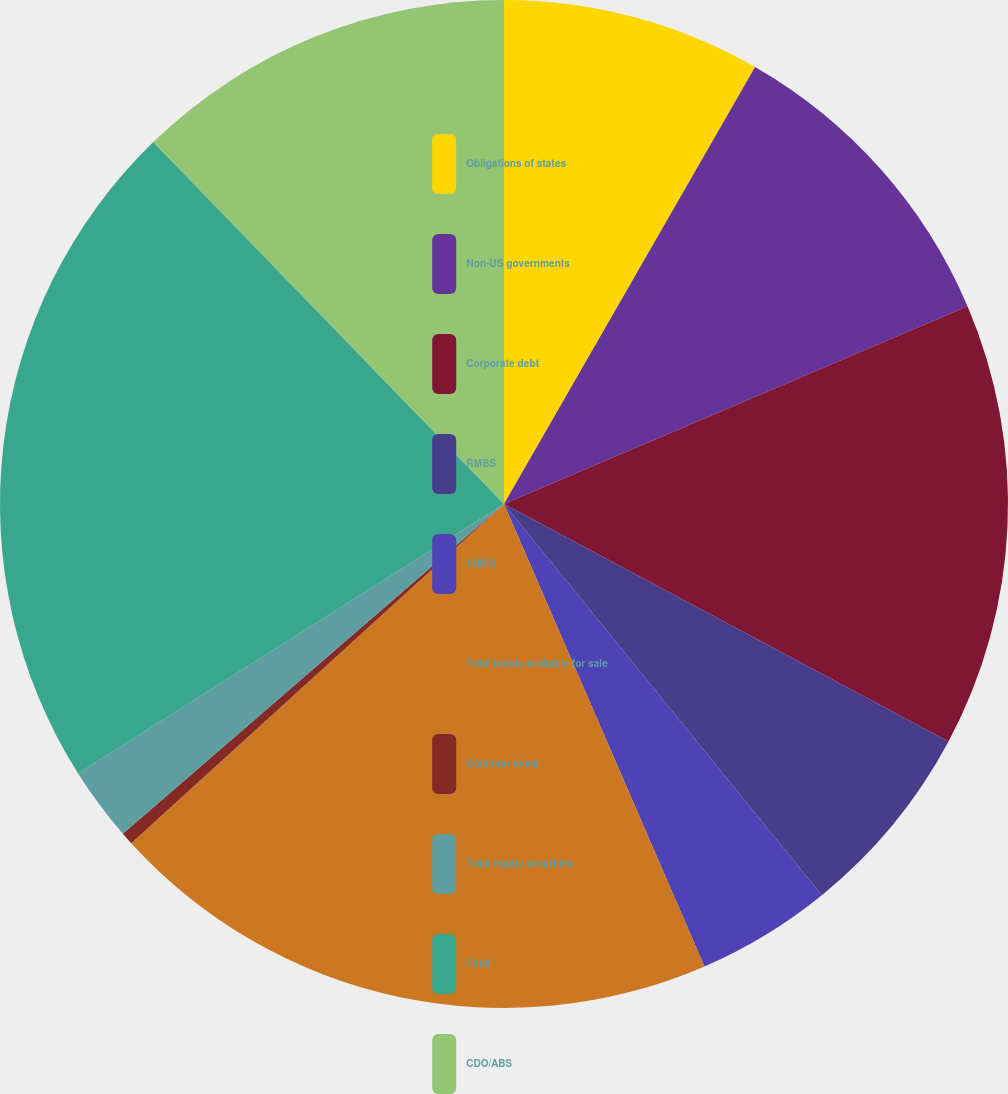Convert chart to OTSL. <chart><loc_0><loc_0><loc_500><loc_500><pie_chart><fcel>Obligations of states<fcel>Non-US governments<fcel>Corporate debt<fcel>RMBS<fcel>CMBS<fcel>Total bonds available for sale<fcel>Common stock<fcel>Total equity securities<fcel>Total<fcel>CDO/ABS<nl><fcel>8.3%<fcel>10.28%<fcel>14.23%<fcel>6.33%<fcel>4.35%<fcel>19.76%<fcel>0.4%<fcel>2.37%<fcel>21.73%<fcel>12.25%<nl></chart> 